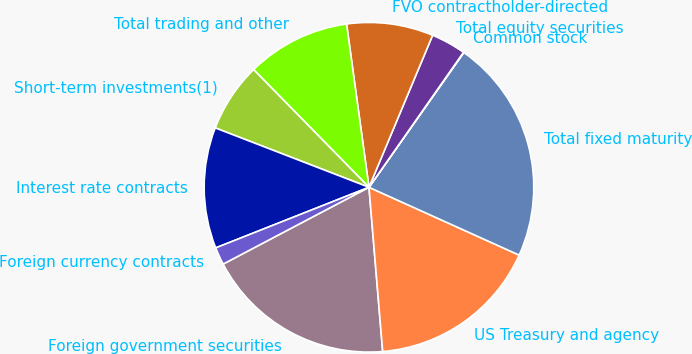Convert chart. <chart><loc_0><loc_0><loc_500><loc_500><pie_chart><fcel>Foreign government securities<fcel>US Treasury and agency<fcel>Total fixed maturity<fcel>Common stock<fcel>Total equity securities<fcel>FVO contractholder-directed<fcel>Total trading and other<fcel>Short-term investments(1)<fcel>Interest rate contracts<fcel>Foreign currency contracts<nl><fcel>18.61%<fcel>16.92%<fcel>21.99%<fcel>0.04%<fcel>3.41%<fcel>8.48%<fcel>10.17%<fcel>6.79%<fcel>11.86%<fcel>1.72%<nl></chart> 